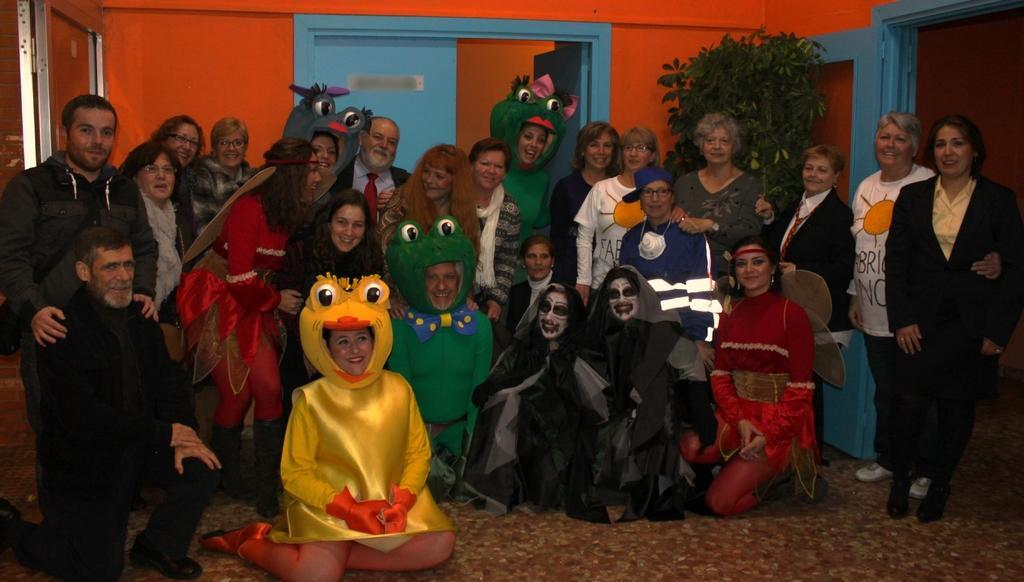In one or two sentences, can you explain what this image depicts? Here we can see a group of people. Few people wore fancy dress. Background there is an orange wall, blue door and plant.  